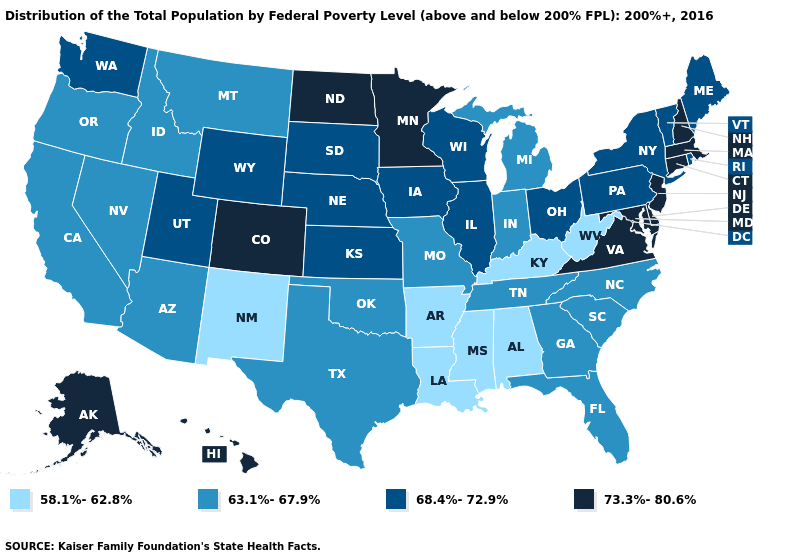Among the states that border Florida , does Alabama have the lowest value?
Concise answer only. Yes. Does Virginia have a higher value than West Virginia?
Keep it brief. Yes. What is the value of Wisconsin?
Quick response, please. 68.4%-72.9%. Among the states that border Montana , does South Dakota have the lowest value?
Give a very brief answer. No. Does Minnesota have a higher value than Alabama?
Quick response, please. Yes. Name the states that have a value in the range 63.1%-67.9%?
Concise answer only. Arizona, California, Florida, Georgia, Idaho, Indiana, Michigan, Missouri, Montana, Nevada, North Carolina, Oklahoma, Oregon, South Carolina, Tennessee, Texas. Does Louisiana have a lower value than Connecticut?
Concise answer only. Yes. What is the value of Georgia?
Write a very short answer. 63.1%-67.9%. Among the states that border New Mexico , which have the lowest value?
Answer briefly. Arizona, Oklahoma, Texas. What is the highest value in the South ?
Keep it brief. 73.3%-80.6%. Name the states that have a value in the range 68.4%-72.9%?
Give a very brief answer. Illinois, Iowa, Kansas, Maine, Nebraska, New York, Ohio, Pennsylvania, Rhode Island, South Dakota, Utah, Vermont, Washington, Wisconsin, Wyoming. What is the value of Virginia?
Keep it brief. 73.3%-80.6%. Which states have the lowest value in the USA?
Quick response, please. Alabama, Arkansas, Kentucky, Louisiana, Mississippi, New Mexico, West Virginia. Does Wyoming have the lowest value in the West?
Short answer required. No. 